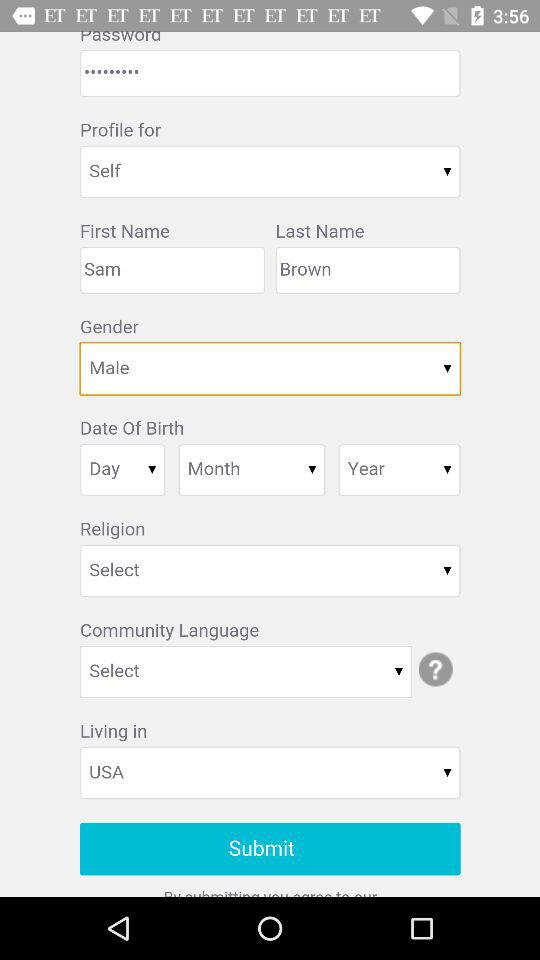Who is this profile for? This profile is for Sam Brown. 